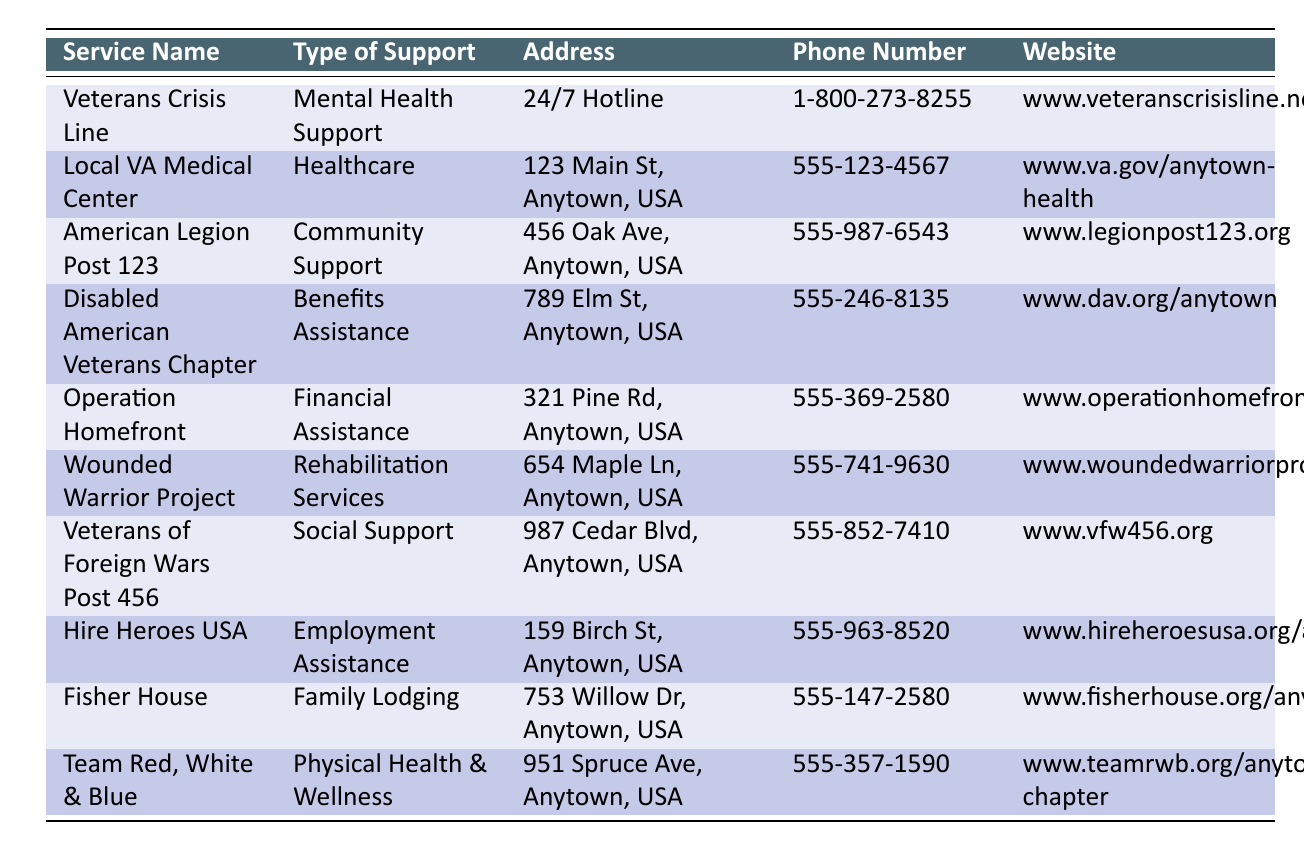What type of support does the American Legion Post 123 provide? The table lists the type of support offered by each service. In the row for the American Legion Post 123, it states that the type of support is Community Support.
Answer: Community Support What is the phone number for the Wounded Warrior Project? Referring to the Wounded Warrior Project row, the phone number provided is 555-741-9630.
Answer: 555-741-9630 Is the Veterans Crisis Line available 24/7? The table indicates that the Veterans Crisis Line operates as a 24/7 Hotline, which confirms its availability at any time.
Answer: Yes How many services listed provide financial assistance? Checking the table, there is one service providing financial assistance: Operation Homefront. Thus, the total is 1.
Answer: 1 Which service provides rehabilitation services and what is their website? The Wounded Warrior Project provides rehabilitation services, and their website is www.woundedwarriorproject.org/anytown.
Answer: www.woundedwarriorproject.org/anytown Are there more services offering physical health support than mental health support? There are two services: Team Red, White & Blue for physical health support and Veterans Crisis Line for mental health support. Since 2 is not greater than 1, the answer is no.
Answer: No What is the address of the Local VA Medical Center? The address listed for the Local VA Medical Center is 123 Main St, Anytown, USA, as recorded in the table.
Answer: 123 Main St, Anytown, USA Which two services have the same phone number as the Disabled American Veterans Chapter? In the table, the Disabled American Veterans Chapter's phone number is 555-246-8135, and upon checking, no other service shares this phone number. Hence, the answer is none.
Answer: None What is the total number of services listed that offer employment assistance? The only service providing employment assistance in the table is Hire Heroes USA, so the total is 1.
Answer: 1 